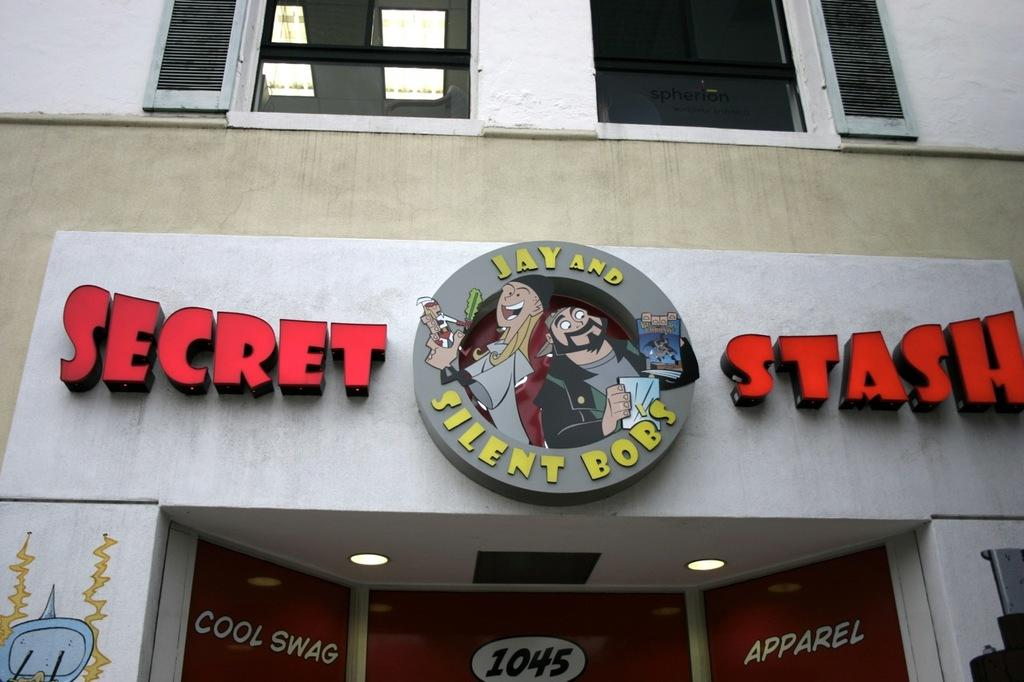<image>
Write a terse but informative summary of the picture. A store front of Jay and Silent Bob's Secret Stash. 